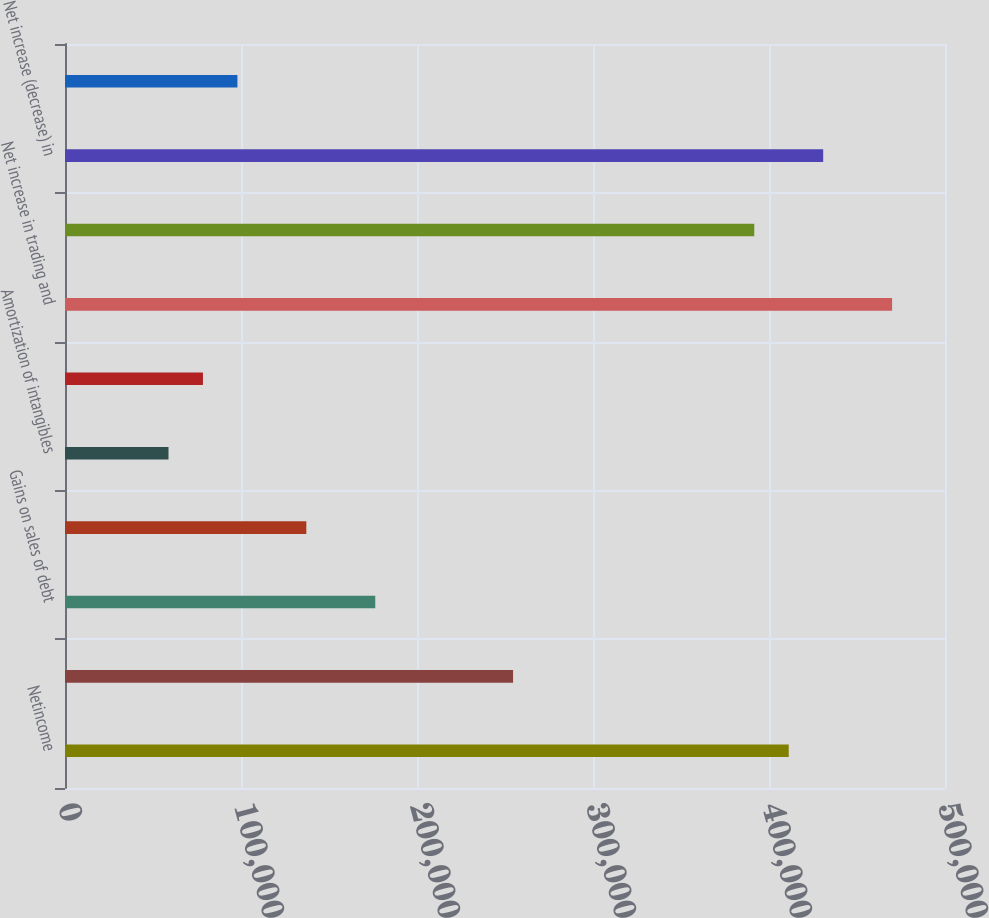Convert chart. <chart><loc_0><loc_0><loc_500><loc_500><bar_chart><fcel>Netincome<fcel>Provision for credit losses<fcel>Gains on sales of debt<fcel>Depreciation and premises<fcel>Amortization of intangibles<fcel>Deferred income tax expense<fcel>Net increase in trading and<fcel>Net (increase) decrease in<fcel>Net increase (decrease) in<fcel>Other operating activities net<nl><fcel>411210<fcel>254586<fcel>176274<fcel>137118<fcel>58806<fcel>78384<fcel>469944<fcel>391632<fcel>430788<fcel>97962<nl></chart> 